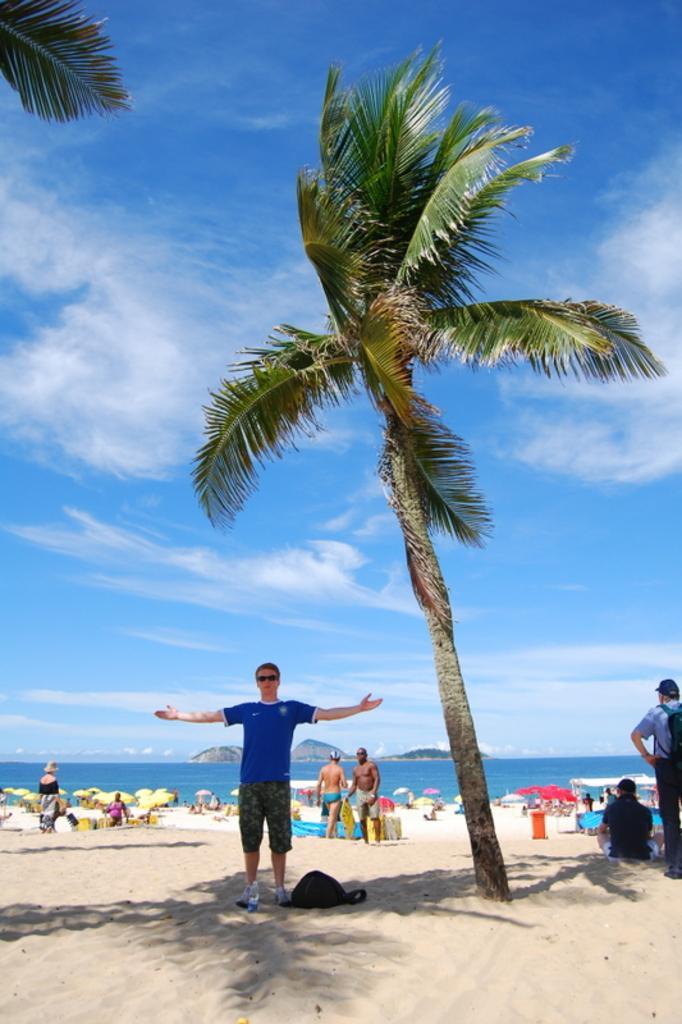In one or two sentences, can you explain what this image depicts? In the picture I can see trees, people among them some are standing and some are sitting on the ground. In the background I can see the sky, the water and mountains. 